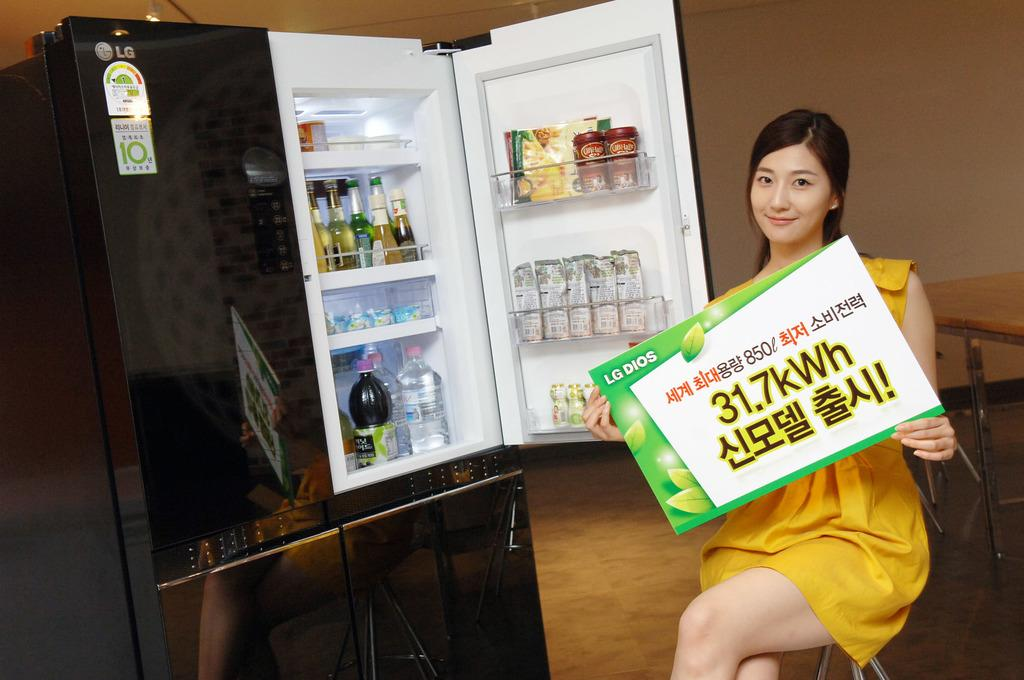<image>
Render a clear and concise summary of the photo. WOman holding a sign in front of a freezer for LG. 